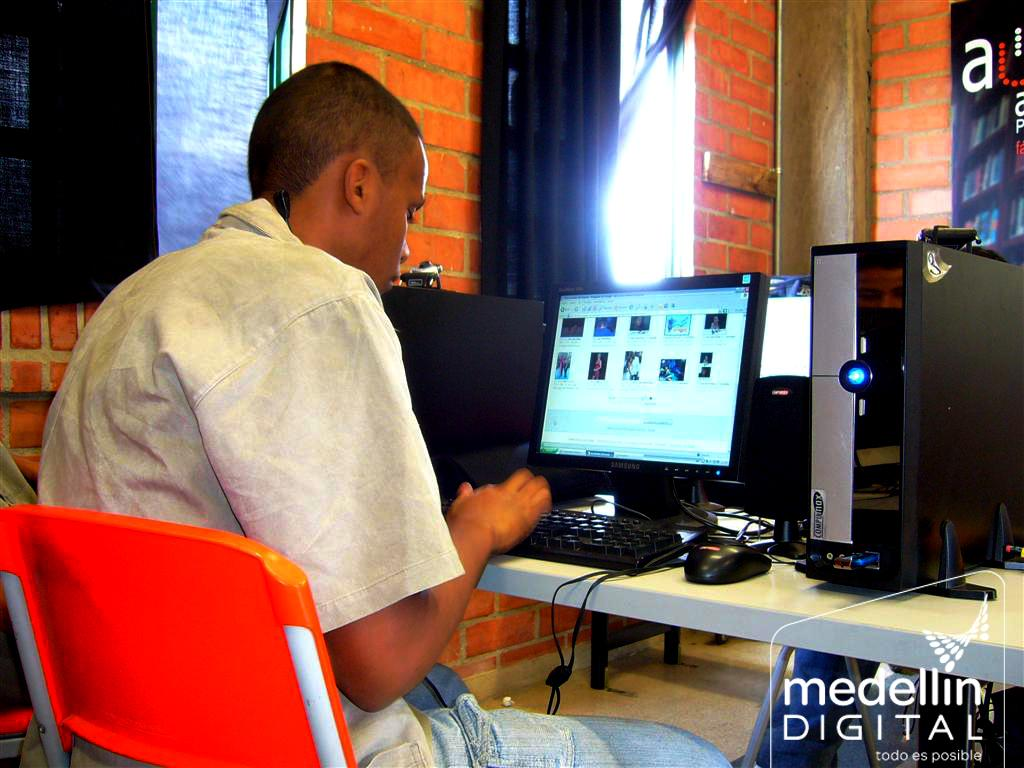<image>
Present a compact description of the photo's key features. A computer user works on a PC in a visual from Medellin Digital. 